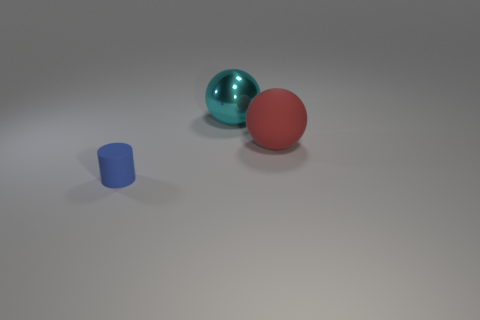Are there any green rubber objects that have the same shape as the big cyan thing?
Provide a succinct answer. No. What material is the blue cylinder?
Your answer should be very brief. Rubber. There is a cyan metallic thing; are there any red matte objects behind it?
Your answer should be very brief. No. Is the shape of the tiny blue rubber object the same as the big cyan metal object?
Make the answer very short. No. How many other things are the same size as the red matte ball?
Your answer should be compact. 1. How many things are rubber things that are to the right of the large cyan ball or small blue objects?
Keep it short and to the point. 2. What is the color of the matte cylinder?
Make the answer very short. Blue. What material is the large object that is in front of the cyan shiny ball?
Your answer should be compact. Rubber. There is a cyan shiny object; does it have the same shape as the large object that is in front of the large cyan sphere?
Your answer should be compact. Yes. Are there more objects than rubber cylinders?
Give a very brief answer. Yes. 